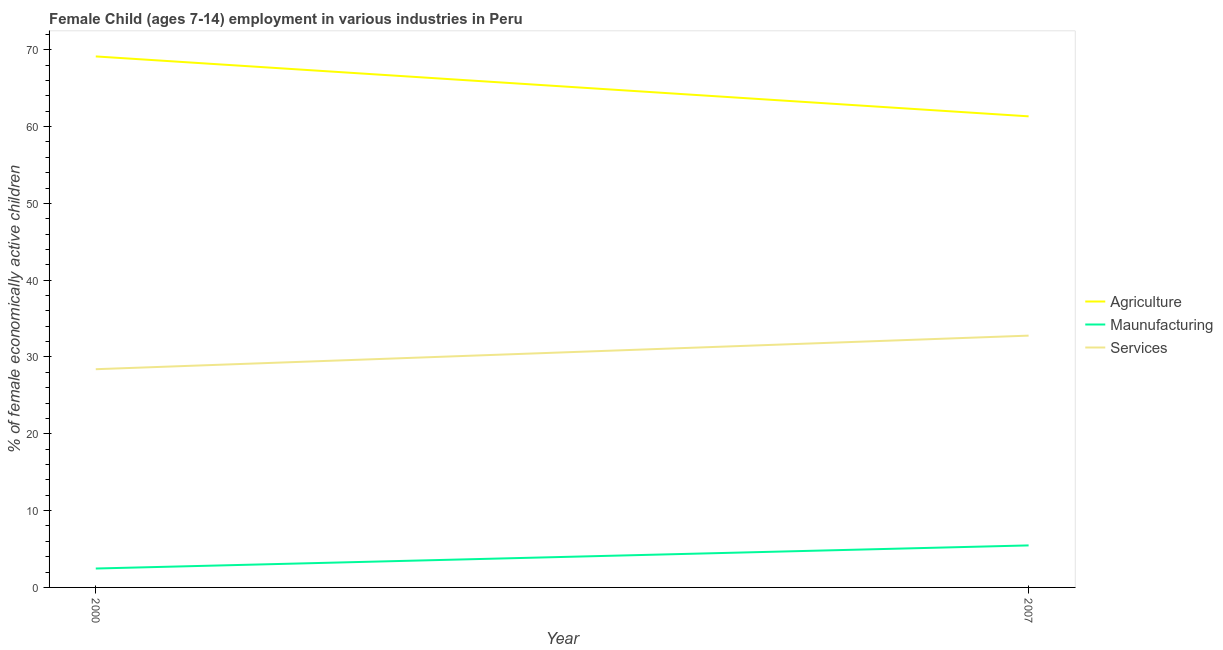Does the line corresponding to percentage of economically active children in manufacturing intersect with the line corresponding to percentage of economically active children in agriculture?
Offer a very short reply. No. Is the number of lines equal to the number of legend labels?
Ensure brevity in your answer.  Yes. What is the percentage of economically active children in agriculture in 2000?
Provide a short and direct response. 69.13. Across all years, what is the maximum percentage of economically active children in services?
Your answer should be very brief. 32.78. Across all years, what is the minimum percentage of economically active children in agriculture?
Your response must be concise. 61.33. In which year was the percentage of economically active children in services maximum?
Provide a short and direct response. 2007. In which year was the percentage of economically active children in manufacturing minimum?
Your answer should be compact. 2000. What is the total percentage of economically active children in agriculture in the graph?
Your answer should be very brief. 130.46. What is the difference between the percentage of economically active children in agriculture in 2000 and that in 2007?
Ensure brevity in your answer.  7.8. What is the difference between the percentage of economically active children in agriculture in 2007 and the percentage of economically active children in manufacturing in 2000?
Offer a terse response. 58.87. What is the average percentage of economically active children in agriculture per year?
Provide a short and direct response. 65.23. In the year 2007, what is the difference between the percentage of economically active children in services and percentage of economically active children in agriculture?
Offer a terse response. -28.55. What is the ratio of the percentage of economically active children in services in 2000 to that in 2007?
Offer a terse response. 0.87. Is the percentage of economically active children in services strictly greater than the percentage of economically active children in agriculture over the years?
Give a very brief answer. No. How many years are there in the graph?
Give a very brief answer. 2. What is the difference between two consecutive major ticks on the Y-axis?
Offer a very short reply. 10. Are the values on the major ticks of Y-axis written in scientific E-notation?
Ensure brevity in your answer.  No. How many legend labels are there?
Your answer should be compact. 3. How are the legend labels stacked?
Your answer should be very brief. Vertical. What is the title of the graph?
Your answer should be very brief. Female Child (ages 7-14) employment in various industries in Peru. What is the label or title of the X-axis?
Keep it short and to the point. Year. What is the label or title of the Y-axis?
Keep it short and to the point. % of female economically active children. What is the % of female economically active children of Agriculture in 2000?
Make the answer very short. 69.13. What is the % of female economically active children of Maunufacturing in 2000?
Your response must be concise. 2.46. What is the % of female economically active children of Services in 2000?
Your answer should be compact. 28.41. What is the % of female economically active children of Agriculture in 2007?
Offer a very short reply. 61.33. What is the % of female economically active children in Maunufacturing in 2007?
Your response must be concise. 5.47. What is the % of female economically active children in Services in 2007?
Offer a very short reply. 32.78. Across all years, what is the maximum % of female economically active children in Agriculture?
Your answer should be compact. 69.13. Across all years, what is the maximum % of female economically active children in Maunufacturing?
Keep it short and to the point. 5.47. Across all years, what is the maximum % of female economically active children in Services?
Make the answer very short. 32.78. Across all years, what is the minimum % of female economically active children in Agriculture?
Your answer should be very brief. 61.33. Across all years, what is the minimum % of female economically active children of Maunufacturing?
Your answer should be compact. 2.46. Across all years, what is the minimum % of female economically active children of Services?
Your answer should be very brief. 28.41. What is the total % of female economically active children of Agriculture in the graph?
Provide a short and direct response. 130.46. What is the total % of female economically active children in Maunufacturing in the graph?
Offer a very short reply. 7.93. What is the total % of female economically active children in Services in the graph?
Keep it short and to the point. 61.19. What is the difference between the % of female economically active children of Agriculture in 2000 and that in 2007?
Offer a terse response. 7.8. What is the difference between the % of female economically active children of Maunufacturing in 2000 and that in 2007?
Your answer should be compact. -3.01. What is the difference between the % of female economically active children in Services in 2000 and that in 2007?
Provide a succinct answer. -4.37. What is the difference between the % of female economically active children of Agriculture in 2000 and the % of female economically active children of Maunufacturing in 2007?
Offer a terse response. 63.66. What is the difference between the % of female economically active children in Agriculture in 2000 and the % of female economically active children in Services in 2007?
Offer a terse response. 36.35. What is the difference between the % of female economically active children of Maunufacturing in 2000 and the % of female economically active children of Services in 2007?
Ensure brevity in your answer.  -30.32. What is the average % of female economically active children of Agriculture per year?
Provide a short and direct response. 65.23. What is the average % of female economically active children of Maunufacturing per year?
Offer a terse response. 3.96. What is the average % of female economically active children of Services per year?
Offer a very short reply. 30.59. In the year 2000, what is the difference between the % of female economically active children of Agriculture and % of female economically active children of Maunufacturing?
Provide a succinct answer. 66.67. In the year 2000, what is the difference between the % of female economically active children in Agriculture and % of female economically active children in Services?
Provide a short and direct response. 40.72. In the year 2000, what is the difference between the % of female economically active children of Maunufacturing and % of female economically active children of Services?
Give a very brief answer. -25.95. In the year 2007, what is the difference between the % of female economically active children of Agriculture and % of female economically active children of Maunufacturing?
Ensure brevity in your answer.  55.86. In the year 2007, what is the difference between the % of female economically active children of Agriculture and % of female economically active children of Services?
Ensure brevity in your answer.  28.55. In the year 2007, what is the difference between the % of female economically active children of Maunufacturing and % of female economically active children of Services?
Provide a succinct answer. -27.31. What is the ratio of the % of female economically active children of Agriculture in 2000 to that in 2007?
Keep it short and to the point. 1.13. What is the ratio of the % of female economically active children of Maunufacturing in 2000 to that in 2007?
Your answer should be compact. 0.45. What is the ratio of the % of female economically active children in Services in 2000 to that in 2007?
Provide a succinct answer. 0.87. What is the difference between the highest and the second highest % of female economically active children of Maunufacturing?
Keep it short and to the point. 3.01. What is the difference between the highest and the second highest % of female economically active children in Services?
Provide a short and direct response. 4.37. What is the difference between the highest and the lowest % of female economically active children in Agriculture?
Give a very brief answer. 7.8. What is the difference between the highest and the lowest % of female economically active children in Maunufacturing?
Offer a terse response. 3.01. What is the difference between the highest and the lowest % of female economically active children of Services?
Make the answer very short. 4.37. 